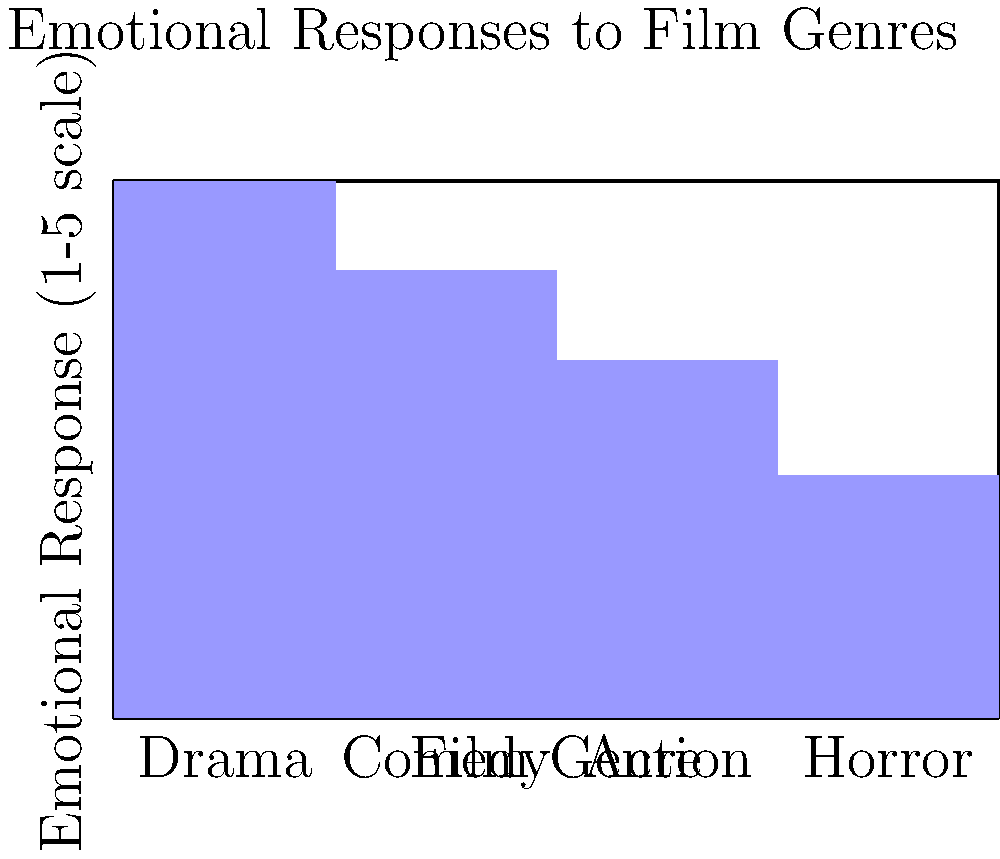Based on the bar chart showing emotional responses to different film genres, which genre elicits the strongest emotional response, and how might this information be relevant in a therapeutic context for survivors of domestic violence? To answer this question, we need to analyze the bar chart and consider its implications for therapy:

1. Examine the bar heights:
   - Drama: 4.2
   - Comedy: 3.5
   - Action: 2.8
   - Horror: 1.9

2. Identify the highest bar:
   Drama has the highest bar at 4.2 on the 1-5 scale.

3. Interpret the result:
   Drama elicits the strongest emotional response among the genres shown.

4. Consider the therapeutic relevance:
   a) Drama films often deal with complex emotions and relationships, which may resonate with survivors' experiences.
   b) Watching and discussing drama films could provide a safe way to explore and process emotions related to past trauma.
   c) The strong emotional response to drama could be used as a tool for emotional regulation exercises in therapy.
   d) Comparing responses to different genres might help survivors understand their emotional triggers and coping mechanisms.
   e) The lower response to horror films might indicate avoidance of intense negative emotions, which could be addressed in therapy.

5. Therapeutic application:
   A social worker could use this information to select appropriate films for discussion, gradually exposing the survivor to more emotionally challenging content as part of the healing process.
Answer: Drama; it elicits the strongest response and can be used therapeutically to explore emotions and experiences safely. 